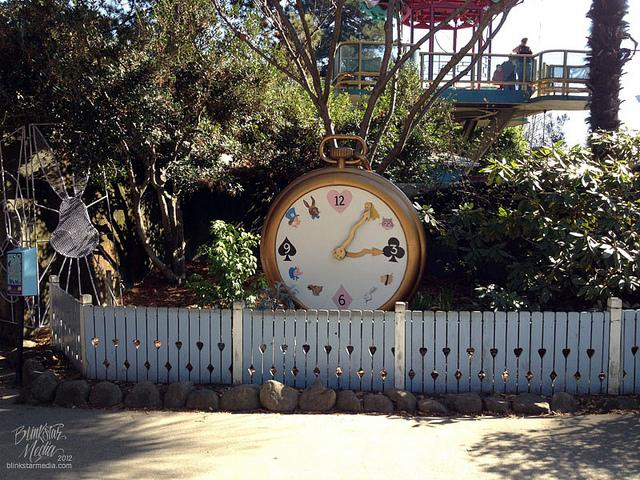This area is based on which author's works?

Choices:
A) lewis carroll
B) agatha christie
C) mark twain
D) stephen king lewis carroll 